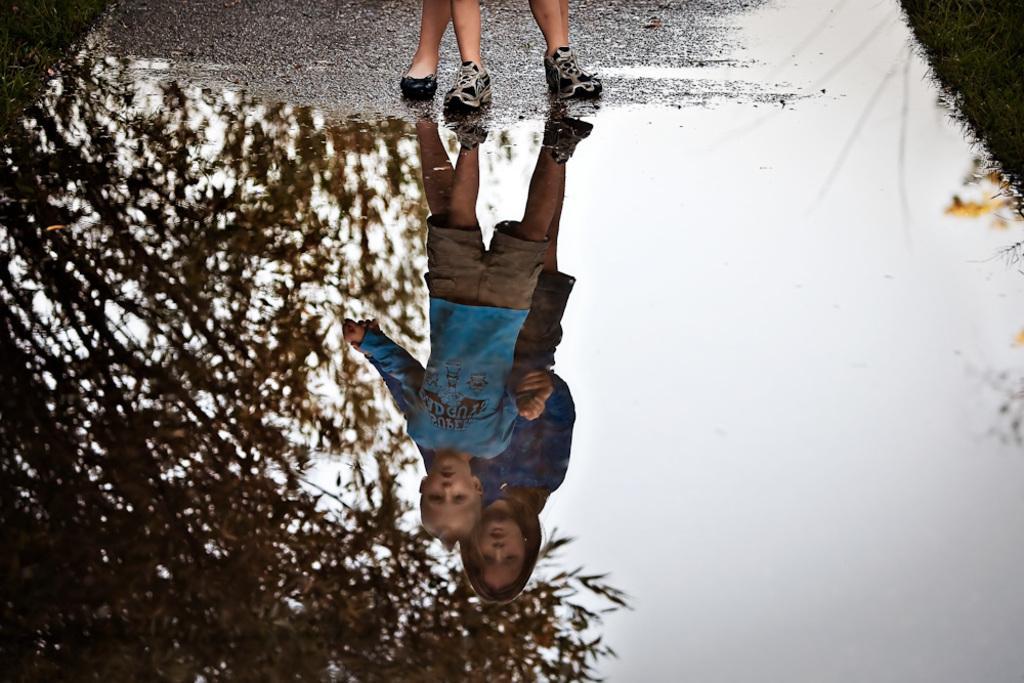Describe this image in one or two sentences. In this picture we can see water and grass, in this water we can see reflection of people, tree and sky. At the top of the image we can see logs of people. 